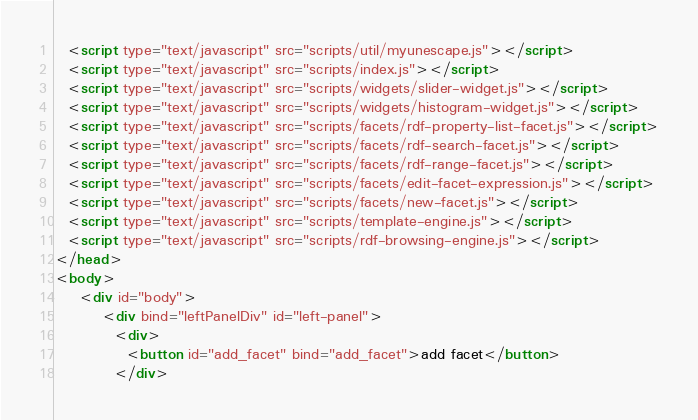<code> <loc_0><loc_0><loc_500><loc_500><_HTML_>  <script type="text/javascript" src="scripts/util/myunescape.js"></script>
  <script type="text/javascript" src="scripts/index.js"></script>
  <script type="text/javascript" src="scripts/widgets/slider-widget.js"></script>
  <script type="text/javascript" src="scripts/widgets/histogram-widget.js"></script>
  <script type="text/javascript" src="scripts/facets/rdf-property-list-facet.js"></script>
  <script type="text/javascript" src="scripts/facets/rdf-search-facet.js"></script>
  <script type="text/javascript" src="scripts/facets/rdf-range-facet.js"></script>
  <script type="text/javascript" src="scripts/facets/edit-facet-expression.js"></script>
  <script type="text/javascript" src="scripts/facets/new-facet.js"></script>
  <script type="text/javascript" src="scripts/template-engine.js"></script>
  <script type="text/javascript" src="scripts/rdf-browsing-engine.js"></script>
</head>
<body>
    <div id="body">
    	<div bind="leftPanelDiv" id="left-panel">
    	  <div>
    	    <button id="add_facet" bind="add_facet">add facet</button>
    	  </div></code> 